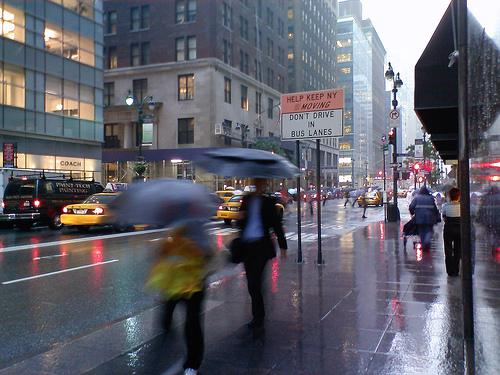Question: what is blurry?
Choices:
A. The people carrying umbrellas.
B. The cars.
C. The animals.
D. The houses.
Answer with the letter. Answer: A Question: where is the black van?
Choices:
A. Next to the curb.
B. Parked in the parking lot.
C. Beside the taxi cab.
D. In front of the cop.
Answer with the letter. Answer: C Question: where was this picture taken?
Choices:
A. In the country.
B. On top of a high building.
C. At a circus.
D. On a busy city street.
Answer with the letter. Answer: D Question: what does the orange part of the sign say?
Choices:
A. Private property.
B. Slow down.
C. Watch for pedestrians.
D. Help keep NY moving.
Answer with the letter. Answer: D Question: where is the Coach store?
Choices:
A. Across the street.
B. Two miles away.
C. On 2nd street.
D. Two blocks south.
Answer with the letter. Answer: A Question: how is the weather?
Choices:
A. It is snowing.
B. It is sunny.
C. It is overcast.
D. It is raining.
Answer with the letter. Answer: D 